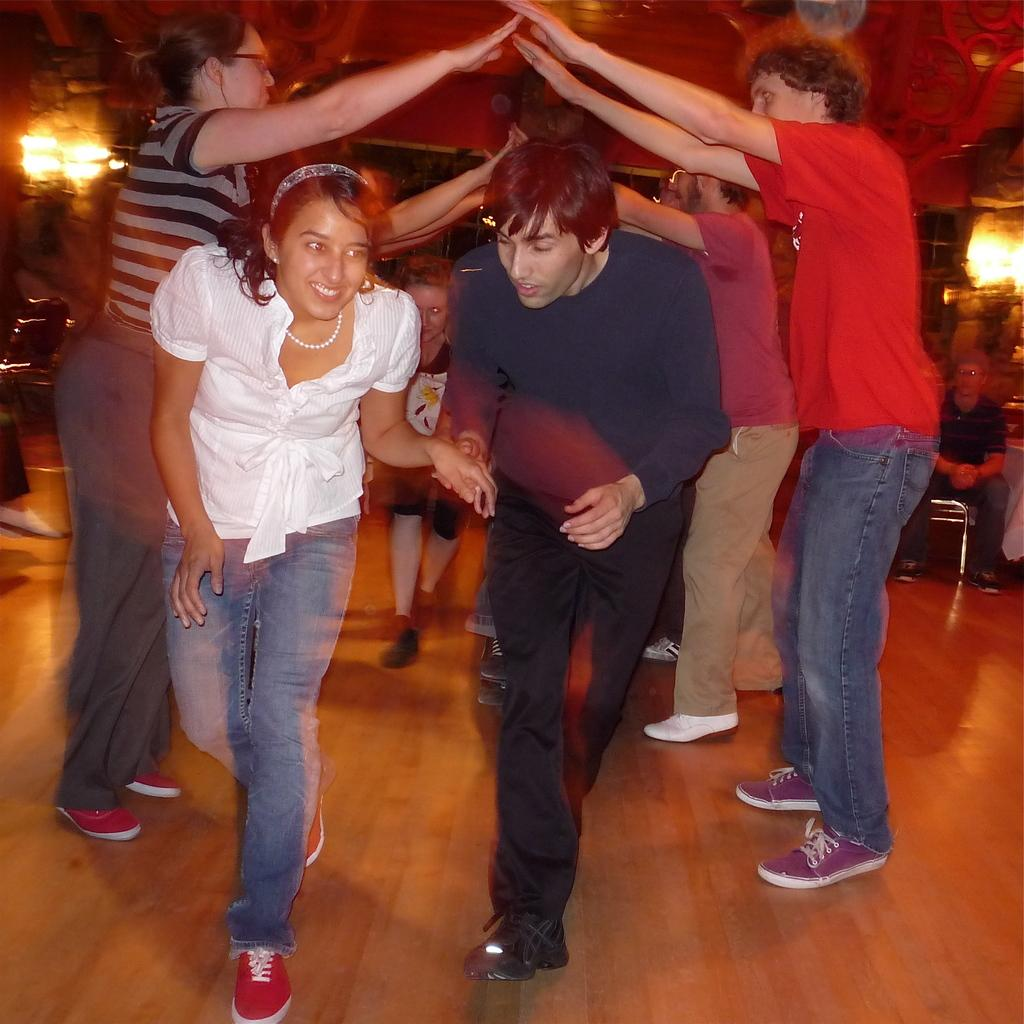What are the people in the image doing? The people in the image are playing. What can be seen in the image besides the people playing? There are lights visible in the image. Can you describe the gender distribution of the people in the image? There are women, men, and a boy in the image. What is the position of the man in the image? The man is seated on a chair in the image. What accessory is the man wearing in the image? The man is wearing spectacles. What type of beetle can be seen crawling on the man's spectacles in the image? There is no beetle present on the man's spectacles in the image. What crime has the man committed, as indicated by the crook in the image? There is no crook or indication of a crime in the image; it simply shows people playing. 